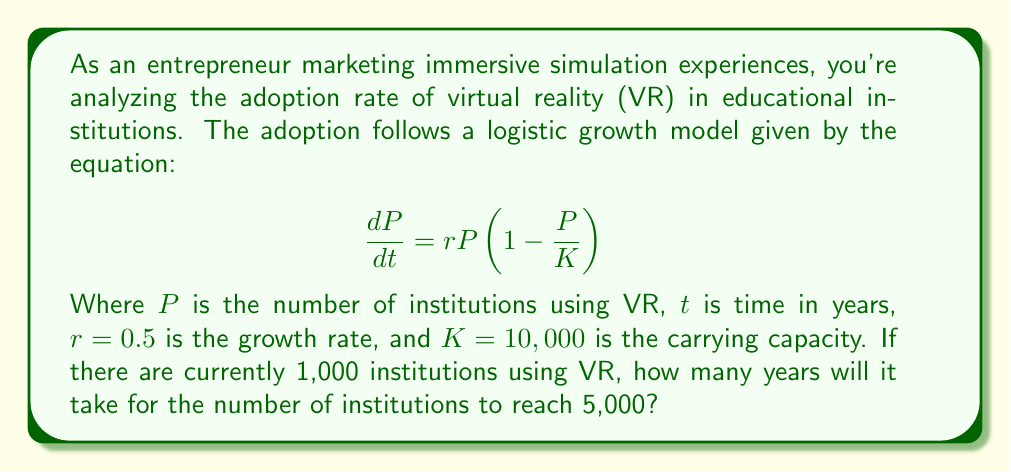Solve this math problem. To solve this problem, we'll use the logistic equation solution:

$$ P(t) = \frac{K}{1 + (\frac{K}{P_0} - 1)e^{-rt}} $$

Where $P_0$ is the initial population (1,000 institutions).

1) Substitute the given values:
   $K = 10,000$, $r = 0.5$, $P_0 = 1,000$, and we want to find $t$ when $P(t) = 5,000$

2) Set up the equation:
   $$ 5,000 = \frac{10,000}{1 + (\frac{10,000}{1,000} - 1)e^{-0.5t}} $$

3) Simplify:
   $$ 5,000 = \frac{10,000}{1 + 9e^{-0.5t}} $$

4) Multiply both sides by the denominator:
   $$ 5,000(1 + 9e^{-0.5t}) = 10,000 $$

5) Distribute:
   $$ 5,000 + 45,000e^{-0.5t} = 10,000 $$

6) Subtract 5,000 from both sides:
   $$ 45,000e^{-0.5t} = 5,000 $$

7) Divide both sides by 45,000:
   $$ e^{-0.5t} = \frac{1}{9} $$

8) Take the natural log of both sides:
   $$ -0.5t = \ln(\frac{1}{9}) = -\ln(9) $$

9) Divide both sides by -0.5:
   $$ t = \frac{\ln(9)}{0.5} \approx 4.39 $$

Therefore, it will take approximately 4.39 years for the number of institutions using VR to reach 5,000.
Answer: 4.39 years 